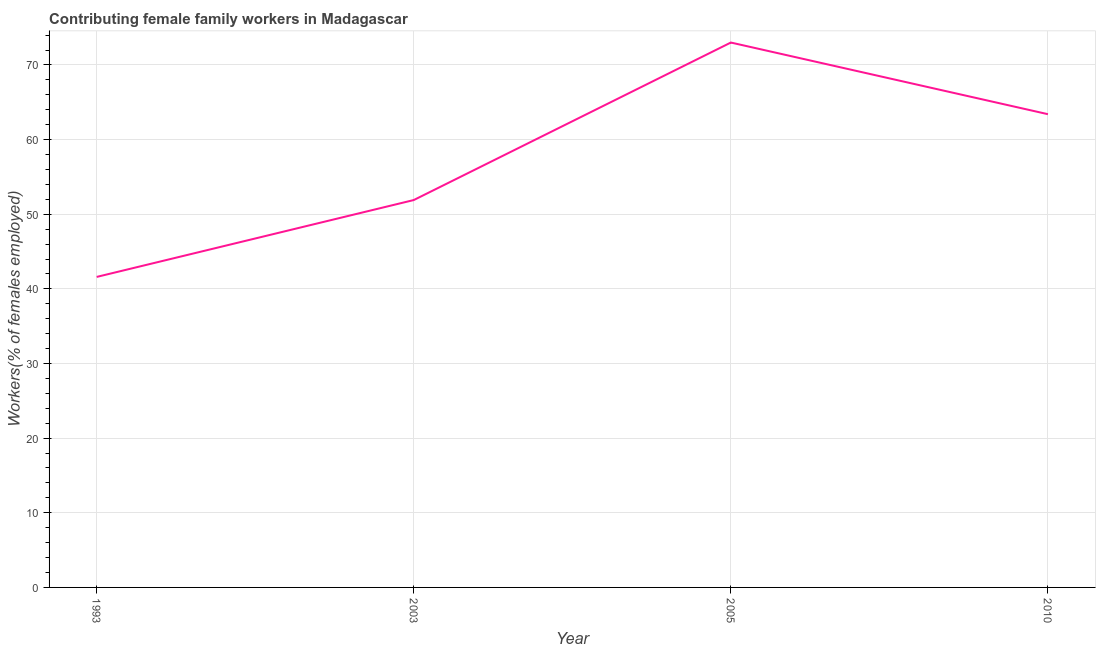What is the contributing female family workers in 2010?
Your response must be concise. 63.4. Across all years, what is the minimum contributing female family workers?
Offer a terse response. 41.6. In which year was the contributing female family workers maximum?
Ensure brevity in your answer.  2005. What is the sum of the contributing female family workers?
Provide a short and direct response. 229.9. What is the difference between the contributing female family workers in 2003 and 2005?
Offer a very short reply. -21.1. What is the average contributing female family workers per year?
Give a very brief answer. 57.48. What is the median contributing female family workers?
Offer a terse response. 57.65. In how many years, is the contributing female family workers greater than 42 %?
Offer a very short reply. 3. What is the ratio of the contributing female family workers in 2005 to that in 2010?
Your response must be concise. 1.15. Is the difference between the contributing female family workers in 1993 and 2005 greater than the difference between any two years?
Keep it short and to the point. Yes. What is the difference between the highest and the second highest contributing female family workers?
Ensure brevity in your answer.  9.6. What is the difference between the highest and the lowest contributing female family workers?
Offer a very short reply. 31.4. Does the contributing female family workers monotonically increase over the years?
Your response must be concise. No. Does the graph contain any zero values?
Give a very brief answer. No. What is the title of the graph?
Make the answer very short. Contributing female family workers in Madagascar. What is the label or title of the Y-axis?
Provide a short and direct response. Workers(% of females employed). What is the Workers(% of females employed) of 1993?
Give a very brief answer. 41.6. What is the Workers(% of females employed) of 2003?
Your answer should be compact. 51.9. What is the Workers(% of females employed) in 2010?
Give a very brief answer. 63.4. What is the difference between the Workers(% of females employed) in 1993 and 2005?
Offer a terse response. -31.4. What is the difference between the Workers(% of females employed) in 1993 and 2010?
Your response must be concise. -21.8. What is the difference between the Workers(% of females employed) in 2003 and 2005?
Offer a very short reply. -21.1. What is the difference between the Workers(% of females employed) in 2003 and 2010?
Your response must be concise. -11.5. What is the ratio of the Workers(% of females employed) in 1993 to that in 2003?
Offer a very short reply. 0.8. What is the ratio of the Workers(% of females employed) in 1993 to that in 2005?
Ensure brevity in your answer.  0.57. What is the ratio of the Workers(% of females employed) in 1993 to that in 2010?
Provide a succinct answer. 0.66. What is the ratio of the Workers(% of females employed) in 2003 to that in 2005?
Provide a short and direct response. 0.71. What is the ratio of the Workers(% of females employed) in 2003 to that in 2010?
Make the answer very short. 0.82. What is the ratio of the Workers(% of females employed) in 2005 to that in 2010?
Offer a very short reply. 1.15. 